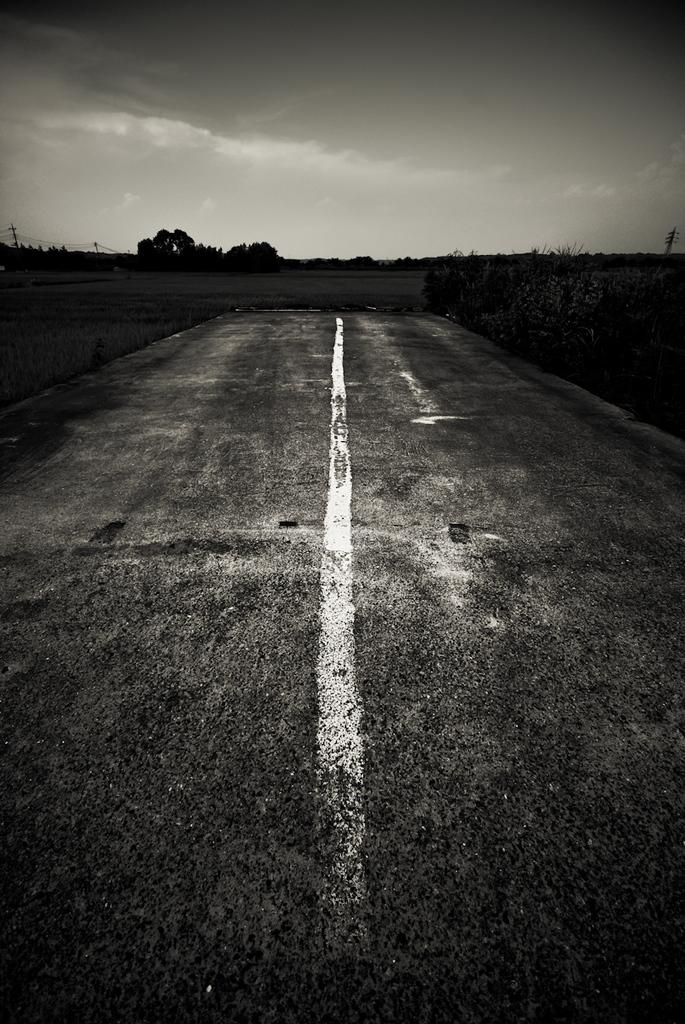What is the main feature of the image? There is a road in the image. What can be seen in the background of the image? There are trees and poles in the background of the image. What is visible in the sky in the image? The sky is visible in the image, and there are clouds in the sky. What type of vegetation is at the bottom of the image? There is grass at the bottom of the image. How many bikes are being ridden by the girl in the image? There is no girl or bikes present in the image. What type of light is illuminating the road in the image? There is no specific light source mentioned or visible in the image; the image only shows a road, trees, poles, sky, clouds, and grass. 